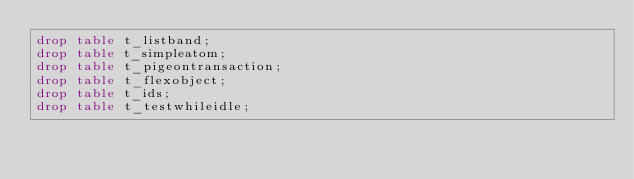Convert code to text. <code><loc_0><loc_0><loc_500><loc_500><_SQL_>drop table t_listband;
drop table t_simpleatom;
drop table t_pigeontransaction;
drop table t_flexobject;
drop table t_ids;
drop table t_testwhileidle;</code> 